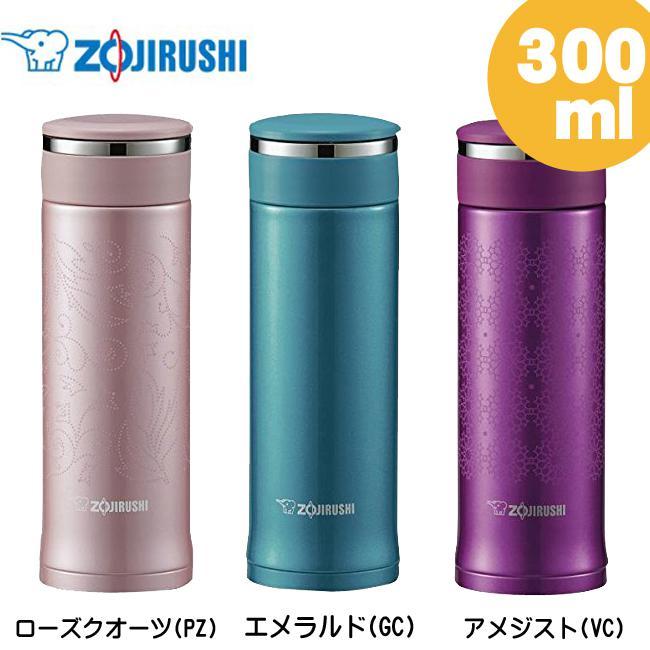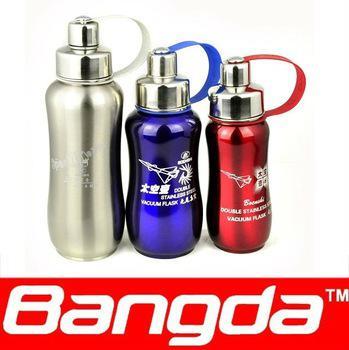The first image is the image on the left, the second image is the image on the right. Assess this claim about the two images: "The left and right image contains the same number of bottles.". Correct or not? Answer yes or no. Yes. The first image is the image on the left, the second image is the image on the right. Analyze the images presented: Is the assertion "The left image include blue, lavender and purple water bottles, and the right image includes silver, red and blue bottles, as well as three 'loops' on bottles." valid? Answer yes or no. Yes. 